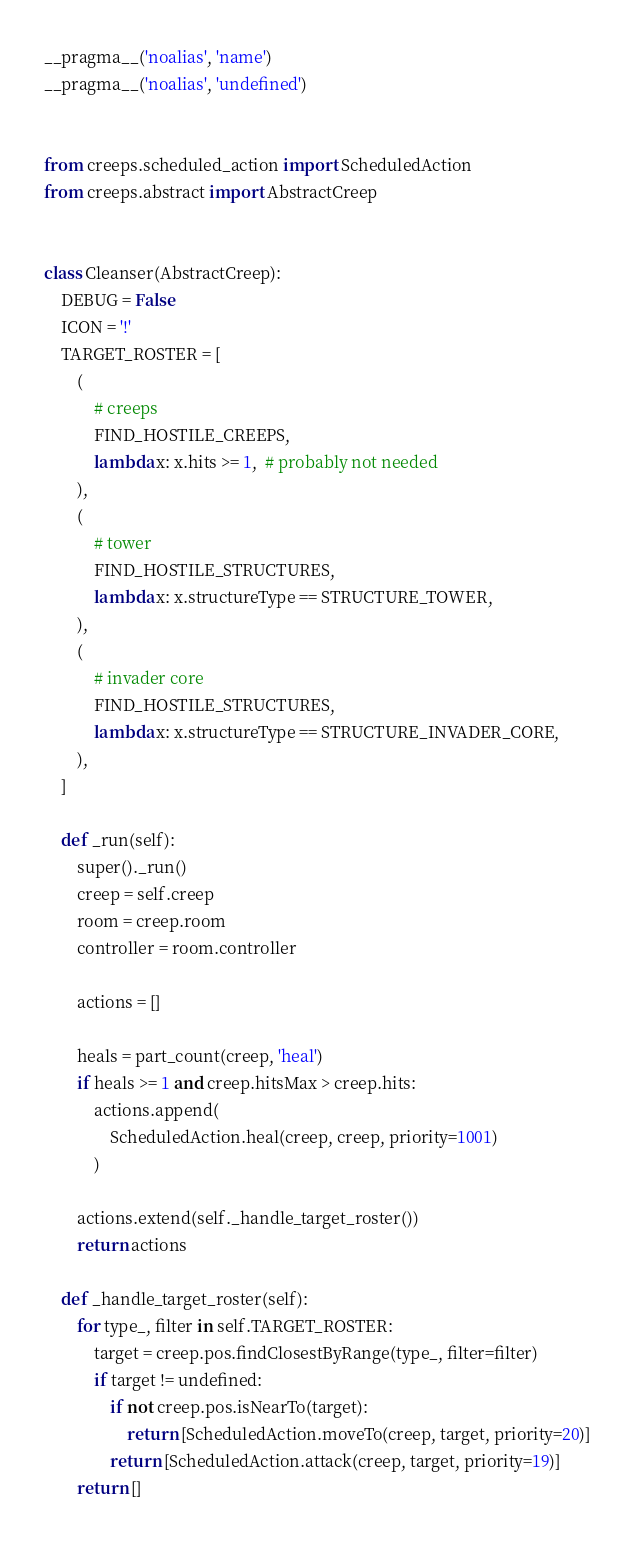Convert code to text. <code><loc_0><loc_0><loc_500><loc_500><_Python_>__pragma__('noalias', 'name')
__pragma__('noalias', 'undefined')


from creeps.scheduled_action import ScheduledAction
from creeps.abstract import AbstractCreep


class Cleanser(AbstractCreep):
    DEBUG = False
    ICON = '!'
    TARGET_ROSTER = [
        (
            # creeps
            FIND_HOSTILE_CREEPS,
            lambda x: x.hits >= 1,  # probably not needed
        ),
        (
            # tower
            FIND_HOSTILE_STRUCTURES,
            lambda x: x.structureType == STRUCTURE_TOWER,
        ),
        (
            # invader core
            FIND_HOSTILE_STRUCTURES,
            lambda x: x.structureType == STRUCTURE_INVADER_CORE,
        ),
    ]

    def _run(self):
        super()._run()
        creep = self.creep
        room = creep.room
        controller = room.controller

        actions = []

        heals = part_count(creep, 'heal')
        if heals >= 1 and creep.hitsMax > creep.hits:
            actions.append(
                ScheduledAction.heal(creep, creep, priority=1001)
            )

        actions.extend(self._handle_target_roster())
        return actions

    def _handle_target_roster(self):
        for type_, filter in self.TARGET_ROSTER:
            target = creep.pos.findClosestByRange(type_, filter=filter)
            if target != undefined:
                if not creep.pos.isNearTo(target):
                    return [ScheduledAction.moveTo(creep, target, priority=20)]
                return [ScheduledAction.attack(creep, target, priority=19)]
        return []
</code> 